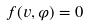<formula> <loc_0><loc_0><loc_500><loc_500>f ( v , \varphi ) = 0</formula> 